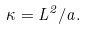Convert formula to latex. <formula><loc_0><loc_0><loc_500><loc_500>\kappa = L ^ { 2 } / a .</formula> 